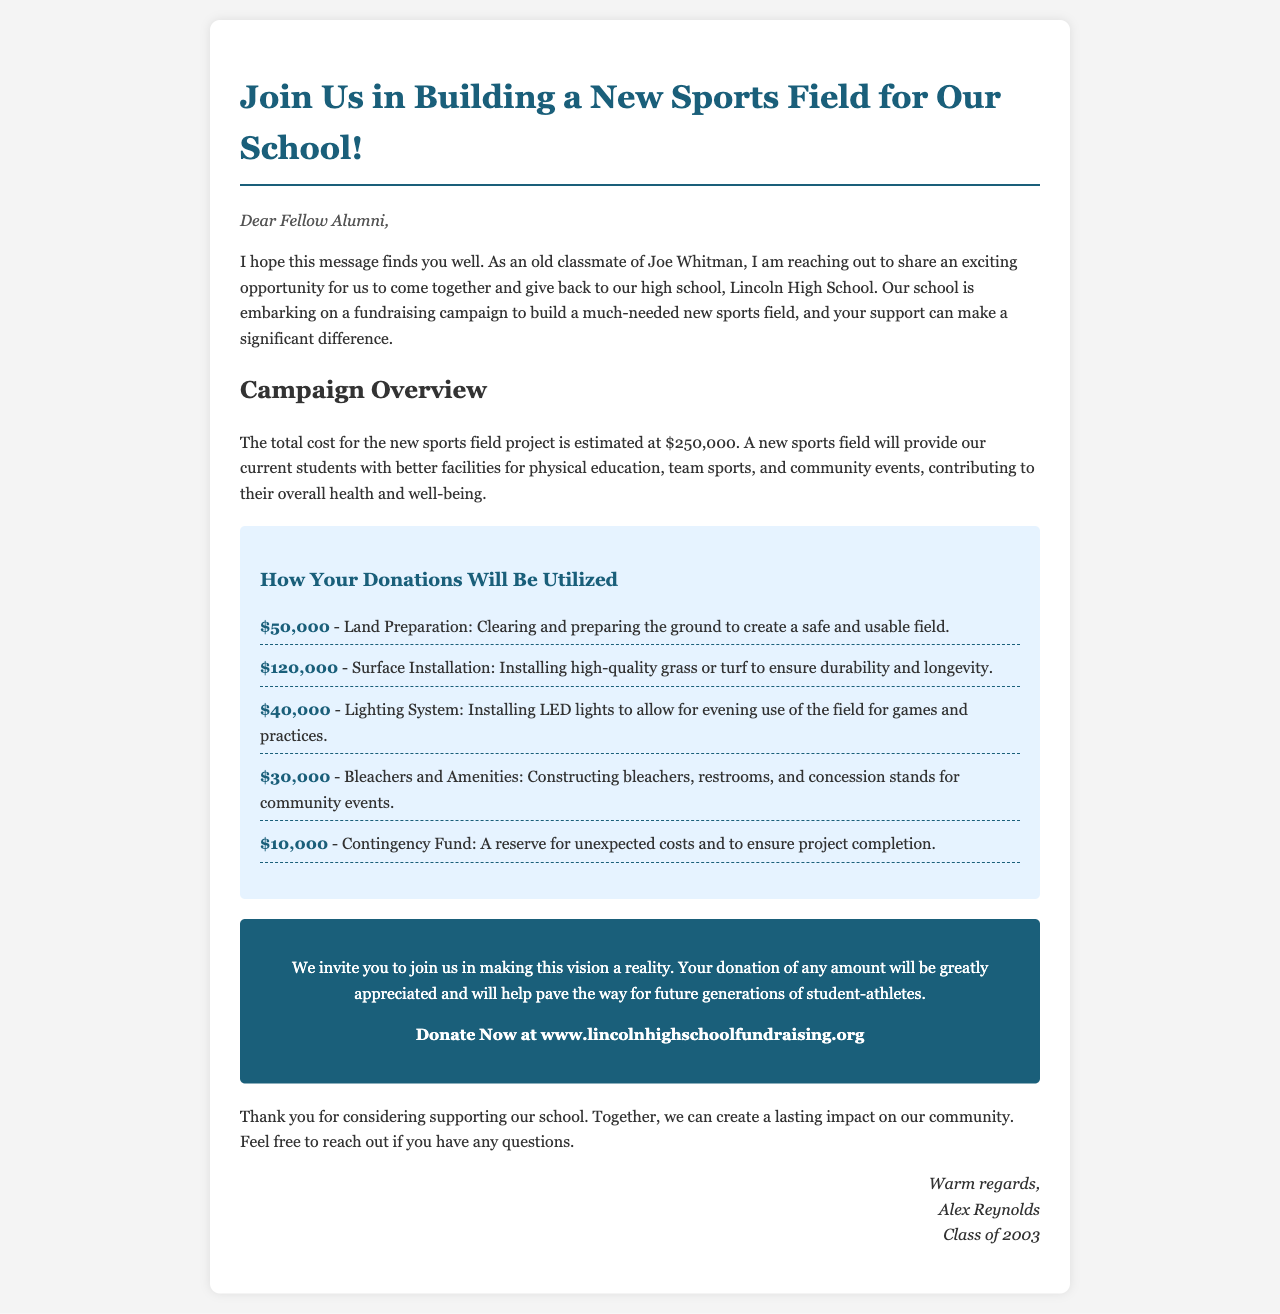What is the total cost for the new sports field project? The total cost for the new sports field project is clearly stated in the document.
Answer: $250,000 How much is allocated for land preparation? The document provides a breakdown of how donations will be utilized, including specific amounts for each area.
Answer: $50,000 Who is the sender of the fundraising appeal? The sender of the appeal is identified at the end of the document.
Answer: Alex Reynolds What will be installed for evening use of the field? The document mentions the installation of specific amenities as part of the fundraising effort.
Answer: Lighting System What portion of funds is set aside for unexpected costs? The document specifies a portion of funds designated for a contingency purpose.
Answer: $10,000 How much funding is dedicated to surface installation? The breakdown includes specific funding amounts for various components, including surface installation.
Answer: $120,000 What type of lighting will be installed? The document indicates the type of lighting system planned for the new sports field.
Answer: LED lights What is the purpose of the new sports field? The document explains the benefits the new field will provide to current students.
Answer: Better facilities for physical education How can someone donate to the fundraising campaign? Specific instructions on how to donate are mentioned in the document.
Answer: www.lincolnhighschoolfundraising.org 